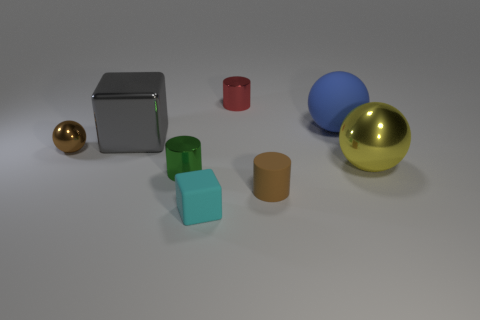Add 1 large yellow shiny things. How many objects exist? 9 Subtract all yellow balls. How many balls are left? 2 Subtract all tiny red metallic cylinders. How many cylinders are left? 2 Subtract 0 gray balls. How many objects are left? 8 Subtract all cubes. How many objects are left? 6 Subtract 3 spheres. How many spheres are left? 0 Subtract all blue cubes. Subtract all yellow spheres. How many cubes are left? 2 Subtract all brown spheres. How many red blocks are left? 0 Subtract all small green shiny things. Subtract all brown things. How many objects are left? 5 Add 8 blue spheres. How many blue spheres are left? 9 